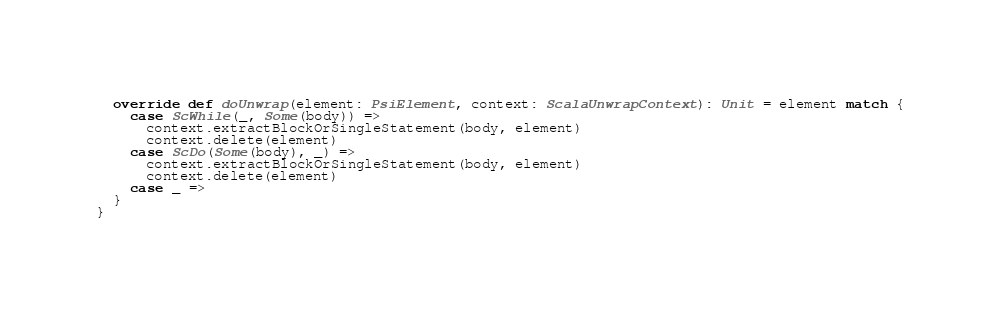Convert code to text. <code><loc_0><loc_0><loc_500><loc_500><_Scala_>
  override def doUnwrap(element: PsiElement, context: ScalaUnwrapContext): Unit = element match {
    case ScWhile(_, Some(body)) =>
      context.extractBlockOrSingleStatement(body, element)
      context.delete(element)
    case ScDo(Some(body), _) =>
      context.extractBlockOrSingleStatement(body, element)
      context.delete(element)
    case _ =>
  }
}
</code> 